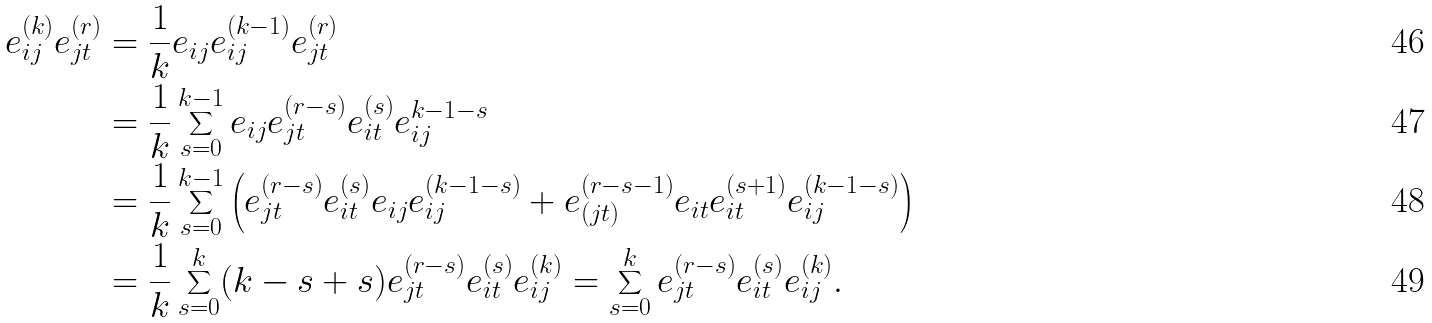<formula> <loc_0><loc_0><loc_500><loc_500>e _ { i j } ^ { ( k ) } e _ { j t } ^ { ( r ) } & = \frac { 1 } { k } e _ { i j } e _ { i j } ^ { ( k - 1 ) } e _ { j t } ^ { ( r ) } \\ & = \frac { 1 } { k } \sum _ { s = 0 } ^ { k - 1 } e _ { i j } e _ { j t } ^ { ( r - s ) } e _ { i t } ^ { ( s ) } e _ { i j } ^ { k - 1 - s } \\ & = \frac { 1 } { k } \sum _ { s = 0 } ^ { k - 1 } \left ( e _ { j t } ^ { ( r - s ) } e _ { i t } ^ { ( s ) } e _ { i j } e _ { i j } ^ { ( k - 1 - s ) } + e _ { ( j t ) } ^ { ( r - s - 1 ) } e _ { i t } e _ { i t } ^ { ( s + 1 ) } e _ { i j } ^ { ( k - 1 - s ) } \right ) \\ & = \frac { 1 } { k } \sum _ { s = 0 } ^ { k } ( k - s + s ) e _ { j t } ^ { ( r - s ) } e _ { i t } ^ { ( s ) } e _ { i j } ^ { ( k ) } = \sum _ { s = 0 } ^ { k } e _ { j t } ^ { ( r - s ) } e _ { i t } ^ { ( s ) } e _ { i j } ^ { ( k ) } .</formula> 